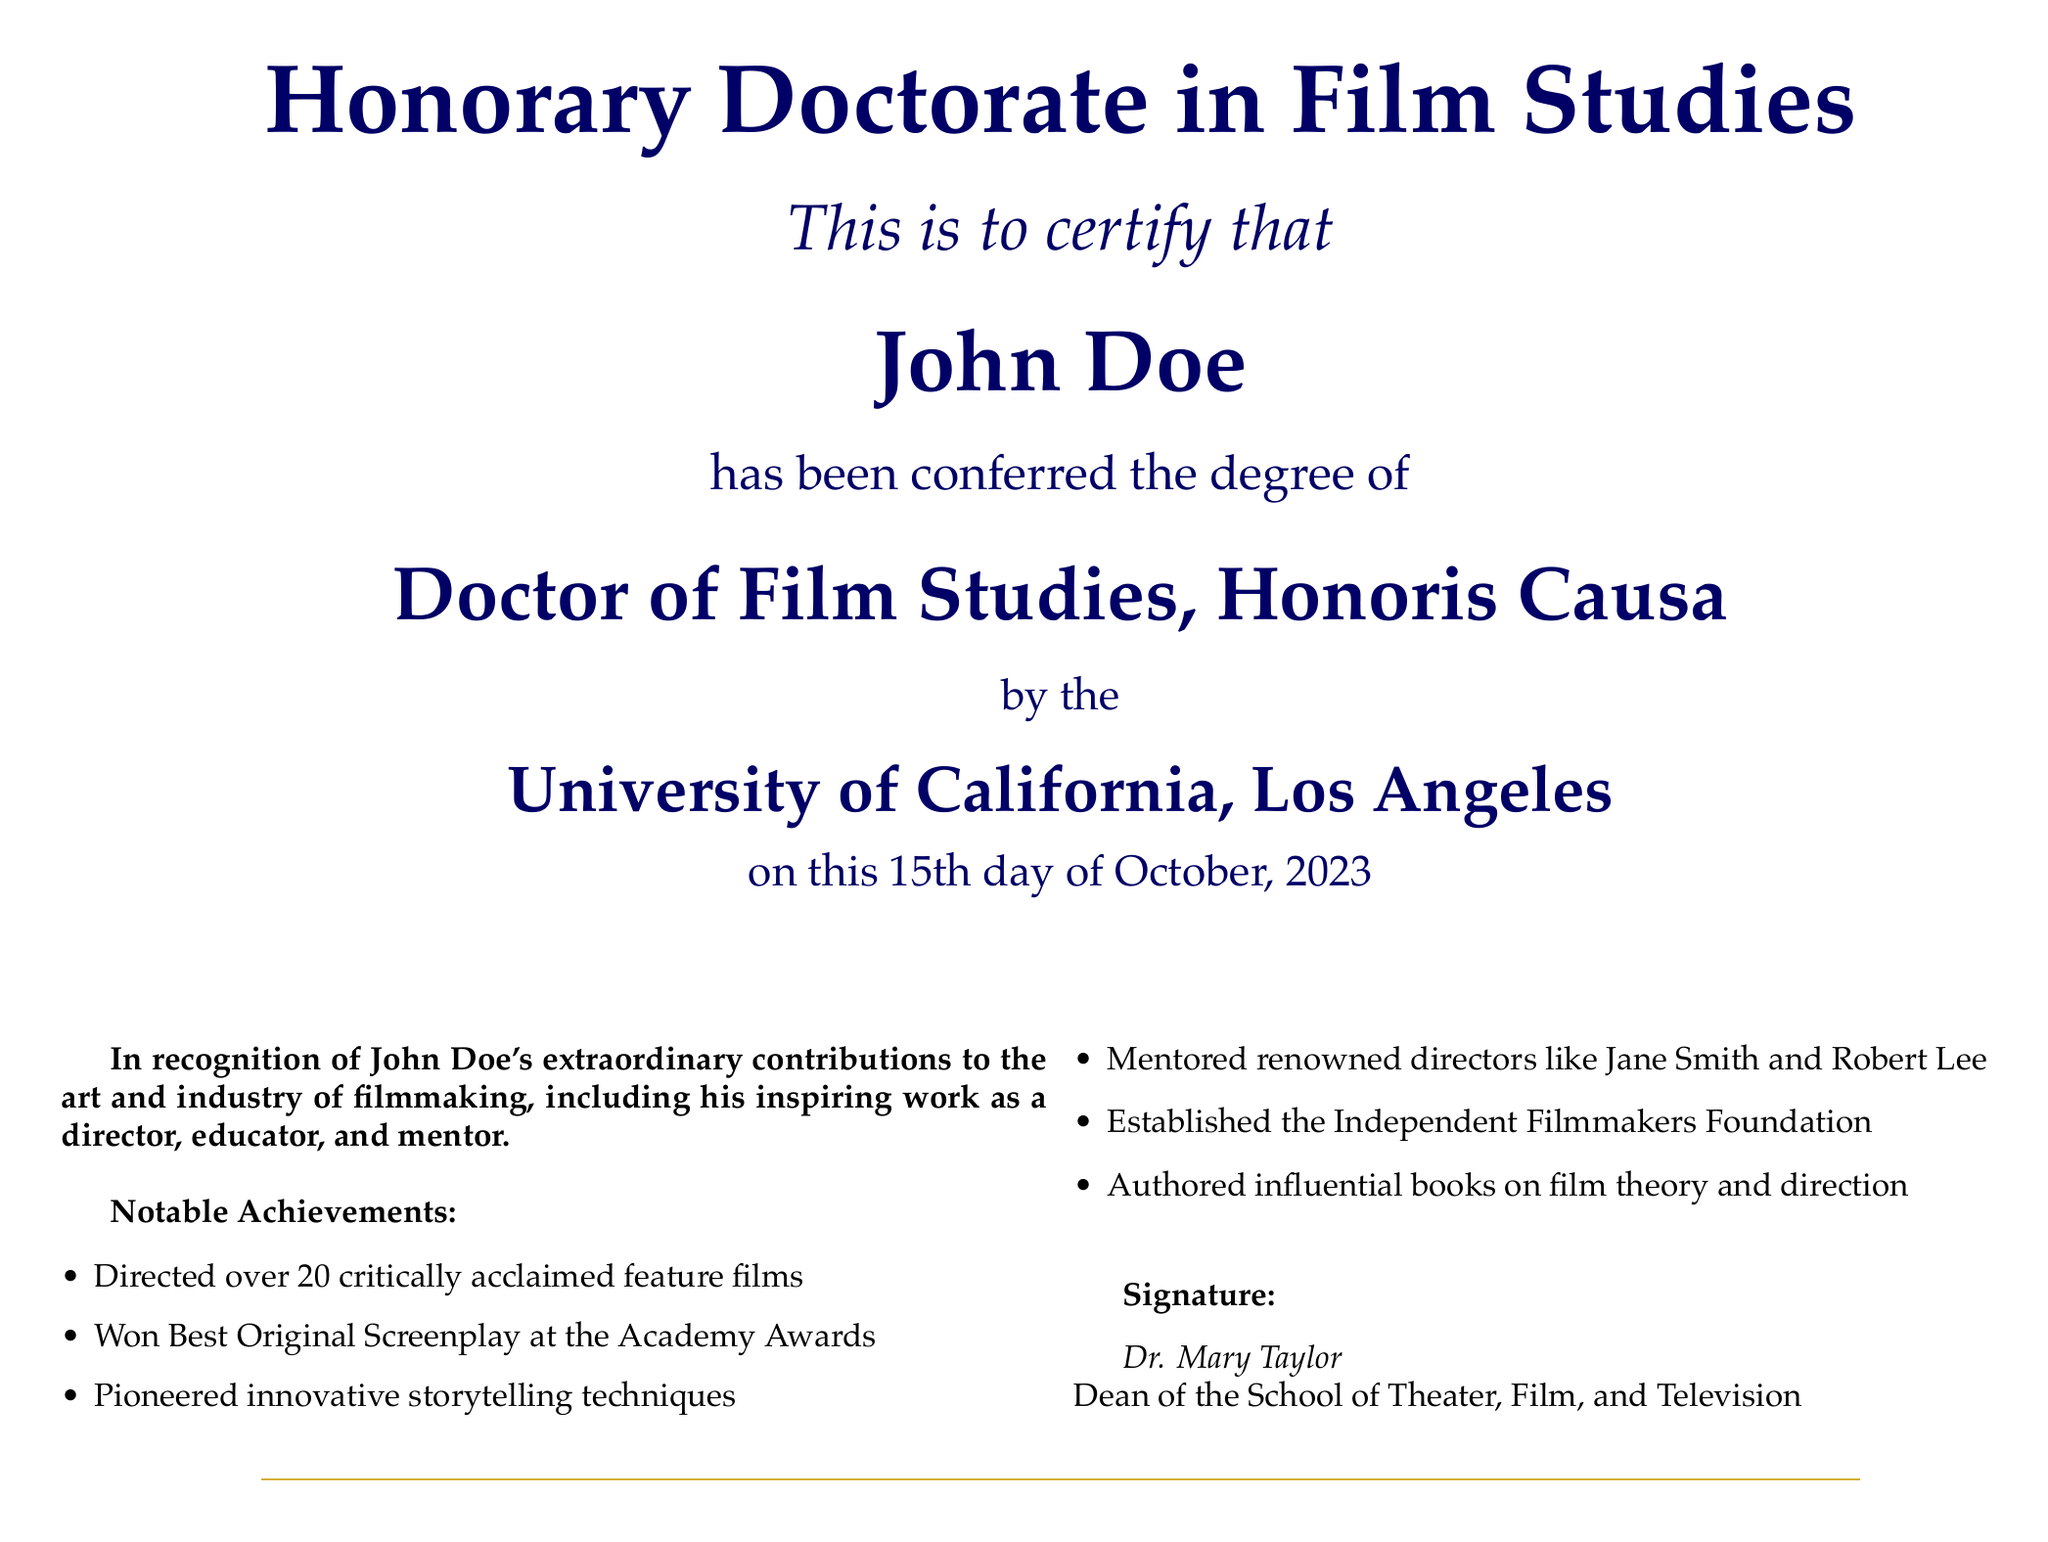What is the title of the degree conferred? The title of the degree conferred is explicitly mentioned in the document as "Doctor of Film Studies, Honoris Causa."
Answer: Doctor of Film Studies, Honoris Causa Who is the recipient of the honorary doctorate? The document names the recipient of the honorary doctorate as "John Doe."
Answer: John Doe When was the honorary doctorate conferred? The specific date mentioned in the document when the degree was conferred is October 15, 2023.
Answer: October 15, 2023 Which university awarded the honorary doctorate? The document states that the degree was awarded by the "University of California, Los Angeles."
Answer: University of California, Los Angeles What is one of John Doe's notable achievements? The document lists several achievements, one being that he "Won Best Original Screenplay at the Academy Awards."
Answer: Won Best Original Screenplay at the Academy Awards How many feature films did John Doe direct? The document states that he directed "over 20 critically acclaimed feature films."
Answer: over 20 What kind of foundation did John Doe establish? The document mentions that he established the "Independent Filmmakers Foundation."
Answer: Independent Filmmakers Foundation Who signed the document? The document mentions that it was signed by "Dr. Mary Taylor."
Answer: Dr. Mary Taylor What role does Dr. Mary Taylor hold? The document specifies that Dr. Mary Taylor is the "Dean of the School of Theater, Film, and Television."
Answer: Dean of the School of Theater, Film, and Television 